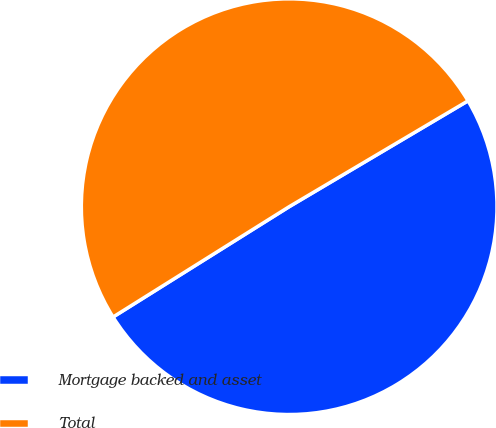Convert chart to OTSL. <chart><loc_0><loc_0><loc_500><loc_500><pie_chart><fcel>Mortgage backed and asset<fcel>Total<nl><fcel>49.6%<fcel>50.4%<nl></chart> 